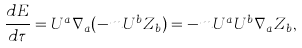<formula> <loc_0><loc_0><loc_500><loc_500>\frac { d E } { d \tau } = U ^ { a } \nabla _ { a } ( - m U ^ { b } Z _ { b } ) = - m U ^ { a } U ^ { b } \nabla _ { a } Z _ { b } ,</formula> 